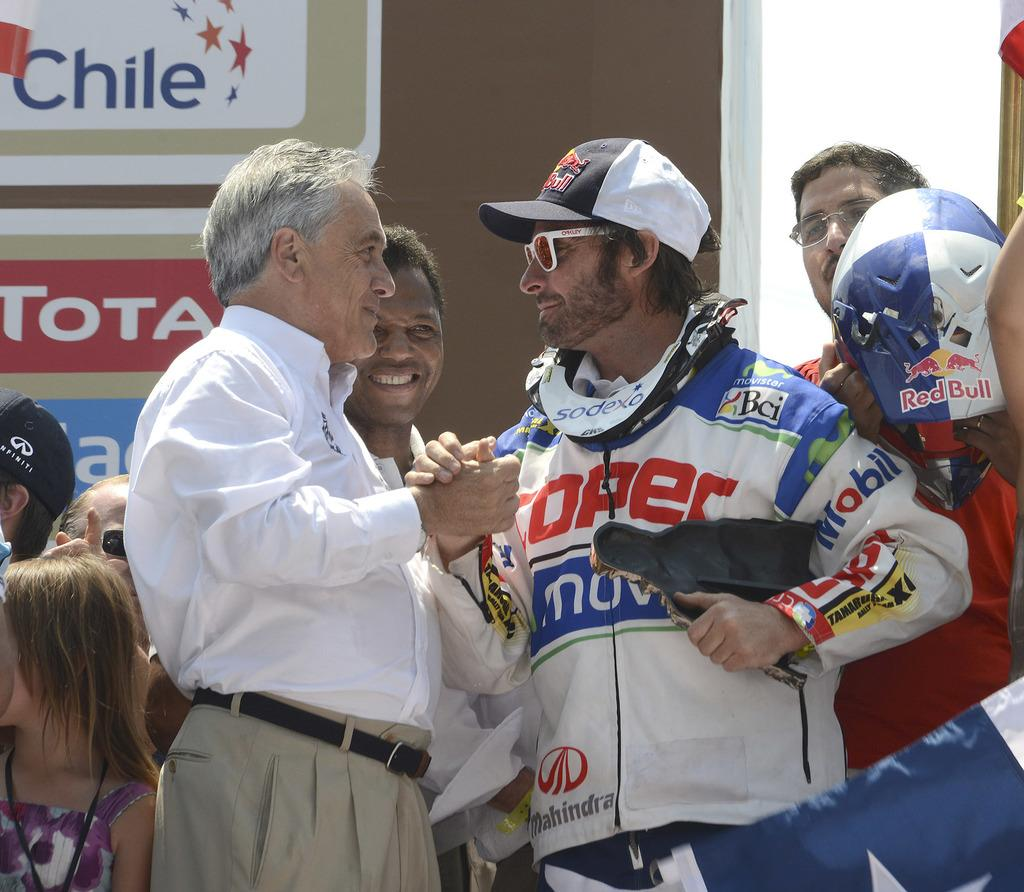<image>
Describe the image concisely. a race car driver from chile being congratulated 